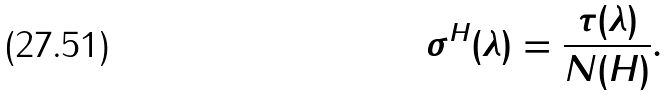<formula> <loc_0><loc_0><loc_500><loc_500>\sigma ^ { H } ( \lambda ) = \frac { \tau ( \lambda ) } { N ( H ) } .</formula> 